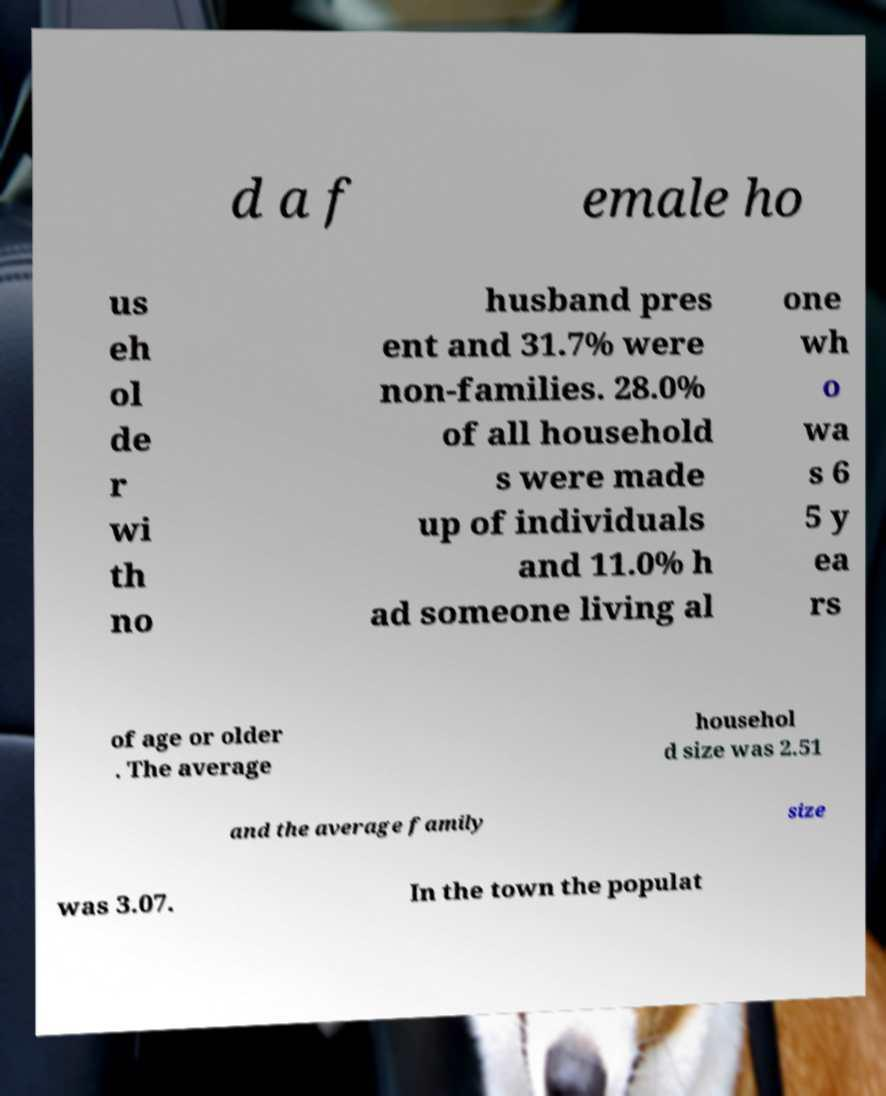What messages or text are displayed in this image? I need them in a readable, typed format. d a f emale ho us eh ol de r wi th no husband pres ent and 31.7% were non-families. 28.0% of all household s were made up of individuals and 11.0% h ad someone living al one wh o wa s 6 5 y ea rs of age or older . The average househol d size was 2.51 and the average family size was 3.07. In the town the populat 